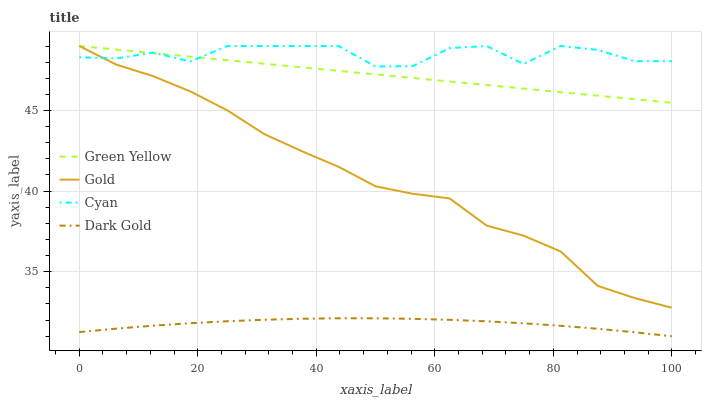Does Green Yellow have the minimum area under the curve?
Answer yes or no. No. Does Green Yellow have the maximum area under the curve?
Answer yes or no. No. Is Gold the smoothest?
Answer yes or no. No. Is Gold the roughest?
Answer yes or no. No. Does Green Yellow have the lowest value?
Answer yes or no. No. Does Dark Gold have the highest value?
Answer yes or no. No. Is Dark Gold less than Cyan?
Answer yes or no. Yes. Is Green Yellow greater than Dark Gold?
Answer yes or no. Yes. Does Dark Gold intersect Cyan?
Answer yes or no. No. 